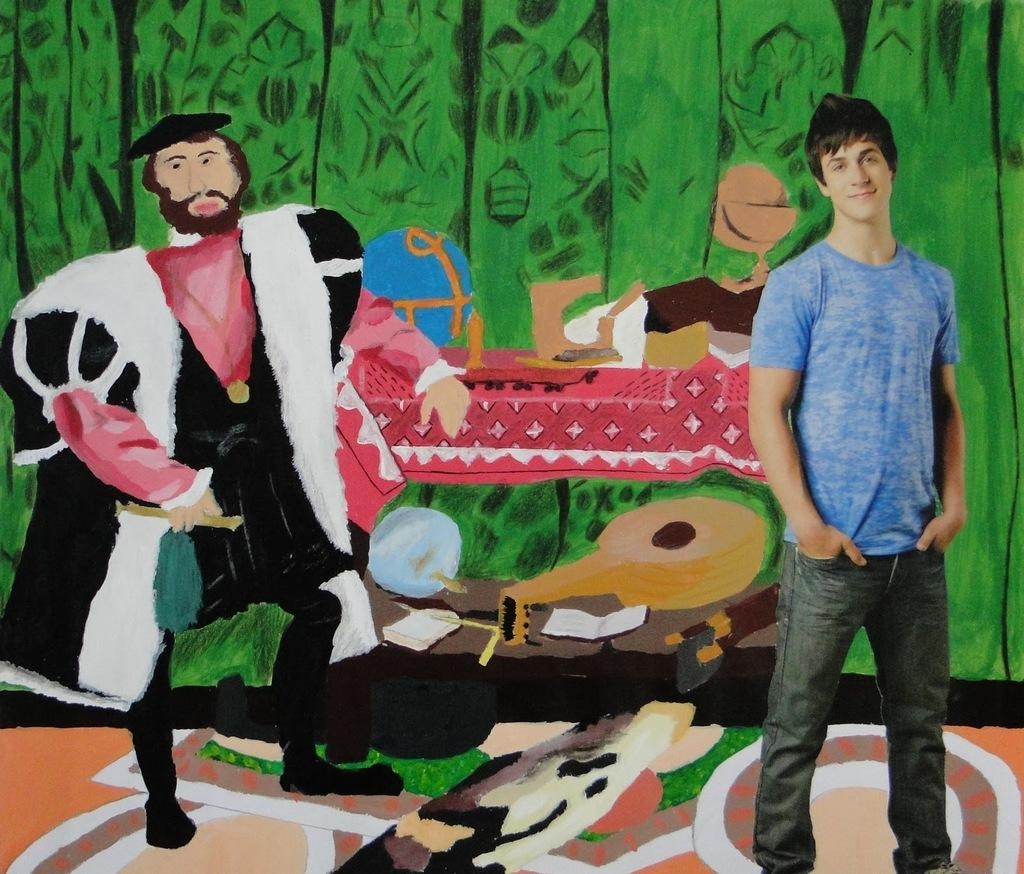Who is the main subject in the image? There is a man in the image. What is the man doing in the image? The man is standing in front. What type of clothing is the man wearing? The man is wearing a t-shirt and pants. What can be seen in the background of the image? There is a wall in the background of the image. What is on the wall in the background? There is an art piece on the wall. How many birds are perched on the cord in the image? There is no cord or birds present in the image. 